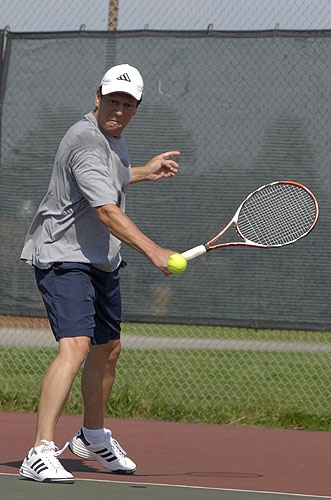Describe the objects in this image and their specific colors. I can see people in darkgray, gray, black, and lightgray tones, tennis racket in darkgray, gray, lightgray, and black tones, and sports ball in darkgray, khaki, and olive tones in this image. 